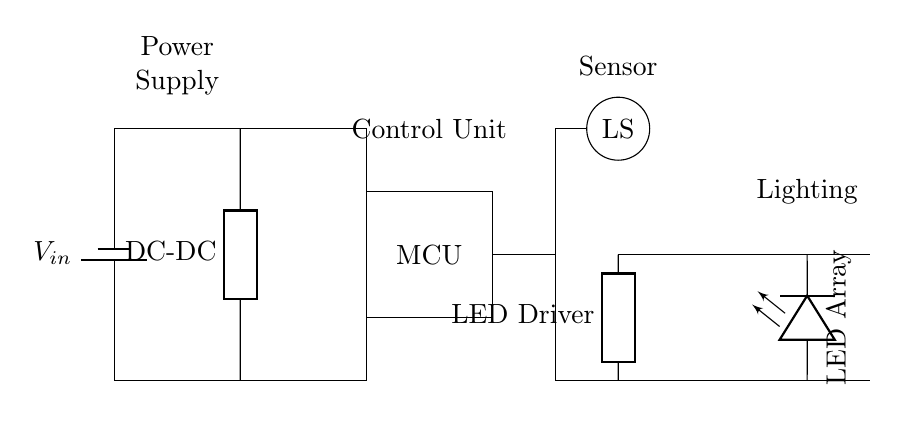What is the role of the component labeled 'MCU'? The component labeled 'MCU' acts as the control unit for the circuit. It processes information, likely from the light sensor, and controls the LED driver based on that input.
Answer: Control unit What type of sensor is used in this circuit? The sensor used is a light sensor, indicated by the label 'LS'. This component detects ambient light levels to assist in managing the lighting system effectively.
Answer: Light sensor How many LEDs are in the LED array? There is one LED shown in the LED array, which is depicted in the diagram. Although an array typically suggests multiple LEDs, this specific diagram only includes one LED.
Answer: One LED What is the function of the DC-DC converter? The DC-DC converter is responsible for converting the input voltage from the battery to a suitable voltage level for the control unit and other components, ensuring efficient power usage across the circuit.
Answer: Voltage conversion How does the light sensor influence the lighting system? The light sensor influences the lighting system by providing feedback to the control unit ('MCU') about ambient light conditions; if it detects sufficient light, the control unit may reduce or turn off the lights to save energy.
Answer: Adjusts lighting based on ambient light What type of power source is used in this circuit? The power source used in this circuit is a battery, as indicated by the symbol labeled 'V_in'. Batteries provide a stable DC voltage necessary for this kind of lighting system.
Answer: Battery What is the purpose of the LED driver? The LED driver is designed to control the power supplied to the LED array, ensuring consistent brightness and performance while managing energy efficiency.
Answer: Control LED power 